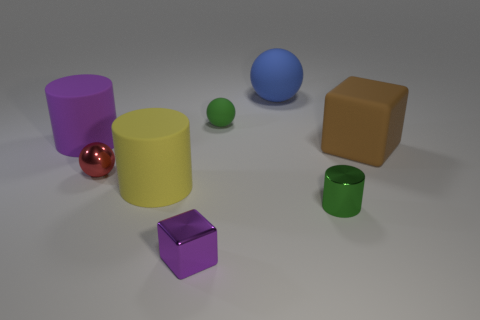Add 1 blue cylinders. How many objects exist? 9 Subtract all cylinders. How many objects are left? 5 Add 4 big rubber cylinders. How many big rubber cylinders are left? 6 Add 2 big blue balls. How many big blue balls exist? 3 Subtract 0 cyan cylinders. How many objects are left? 8 Subtract all green rubber things. Subtract all green balls. How many objects are left? 6 